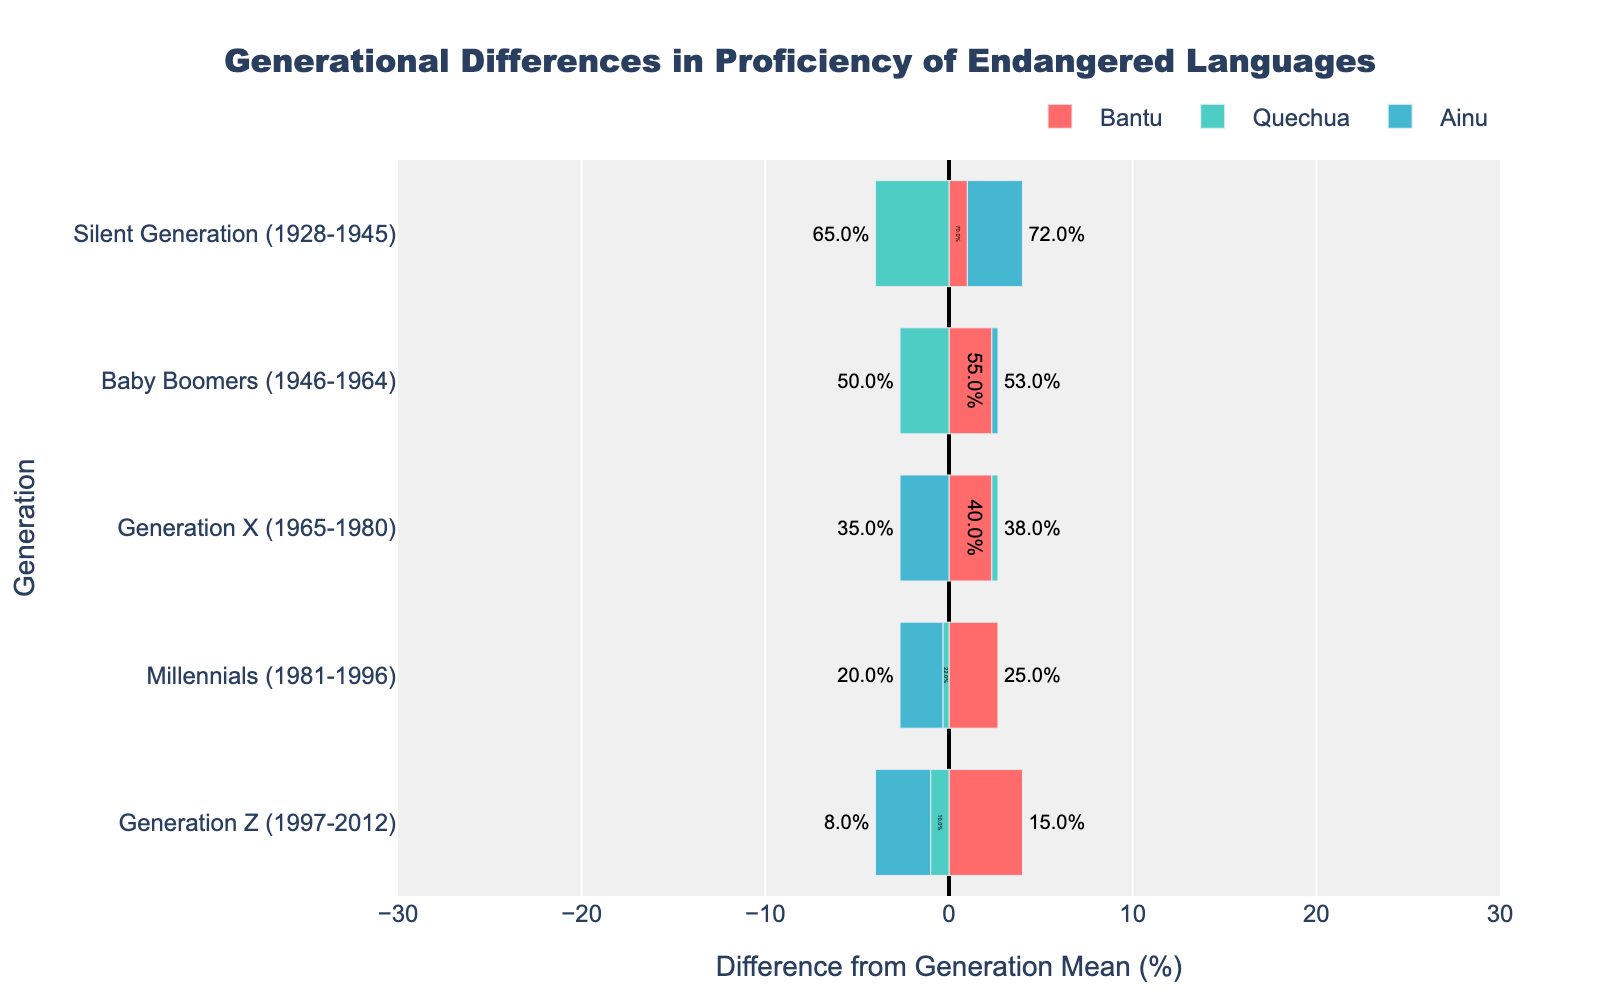1. Which generation has the lowest average proficiency in Ainu? The Silent Generation has an average proficiency of 72%, Baby Boomers have 53%, Generation X has 35%, Millennials have 20%, and Generation Z has 8%. Therefore, Generation Z has the lowest average proficiency in Ainu.
Answer: Generation Z 2. Compare the proficiency levels of the Silent Generation and Millennials for Bantu. The Silent Generation has an average proficiency of 70%, and Millennials have 25%. Comparing these values, the Silent Generation's proficiency level is higher than that of Millennials by 45% for Bantu.
Answer: Silent Generation 3. What is the average difference in proficiency between Baby Boomers and Generation X across all languages? For Bantu, the difference is (55% - 40%) = 15%. For Quechua, the difference is (50% - 38%) = 12%. For Ainu, the difference is (53% - 35%) = 18%. Averaging these differences: (15% + 12% + 18%) / 3 = 15%.
Answer: 15% 4. Which language has the smallest proficiency decrease from Baby Boomers to Millennials? For Bantu, the decrease is (55% - 25%) = 30%. For Quechua, the decrease is (50% - 22%) = 28%. For Ainu, the decrease is (53% - 20%) = 33%. Hence, the smallest decrease is for Quechua.
Answer: Quechua 5. How does the proficiency level of the Silent Generation compare to Baby Boomers for Quechua? The Silent Generation has a proficiency of 65%, while Baby Boomers have 50%. So, the difference is 65% - 50% = 15%. The Silent Generation is more proficient in Quechua by 15%.
Answer: Silent Generation 6. Which generation has the most significant difference in proficiency from the average for Bantu? By examining the divergence of the bars for Bantu, the Silent Generation appears to be the farthest from the mean proficiency, indicating they have the most significant difference.
Answer: Silent Generation 7. Compare the proficiency levels of Generation X and Millennials for all languages combined. For Bantu, Generation X has 40% and Millennials have 25%. For Quechua, Generation X has 38% and Millennials have 22%. For Ainu, Generation X has 35% and Millennials have 20%. Hence, Generation X consistently has higher proficiency levels across all languages compared to Millennials.
Answer: Generation X 8. What is the average proficiency for Quechua across all generations? The proficiency values for Quechua are 65%, 50%, 38%, 22%, and 10%. Sum these values: 65 + 50 + 38 + 22 + 10 = 185. Divide by the number of generations (5): 185 / 5 = 37%.
Answer: 37% 9. Which language has the greatest decline in proficiency from one generation to the next? Assessing the differences, the largest single decline is for Ainu from Millennials (20%) to Generation Z (8%), which is a drop of 12%.
Answer: Ainu 10. How does Generation Z's proficiency in Quechua compare to their proficiency in Bantu? Generation Z has a proficiency of 10% in Quechua and 15% in Bantu. Therefore, their proficiency in Bantu is higher than that in Quechua by 5%.
Answer: Bantu
``` 